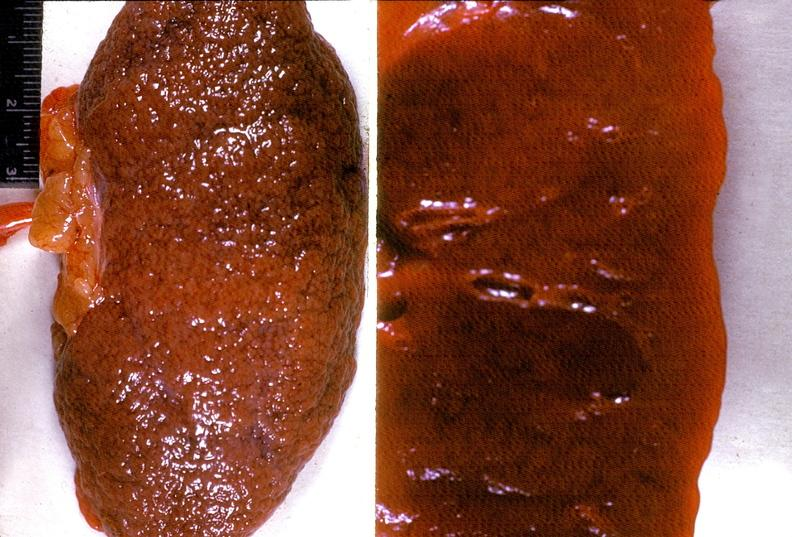what does this image show?
Answer the question using a single word or phrase. Kidney 